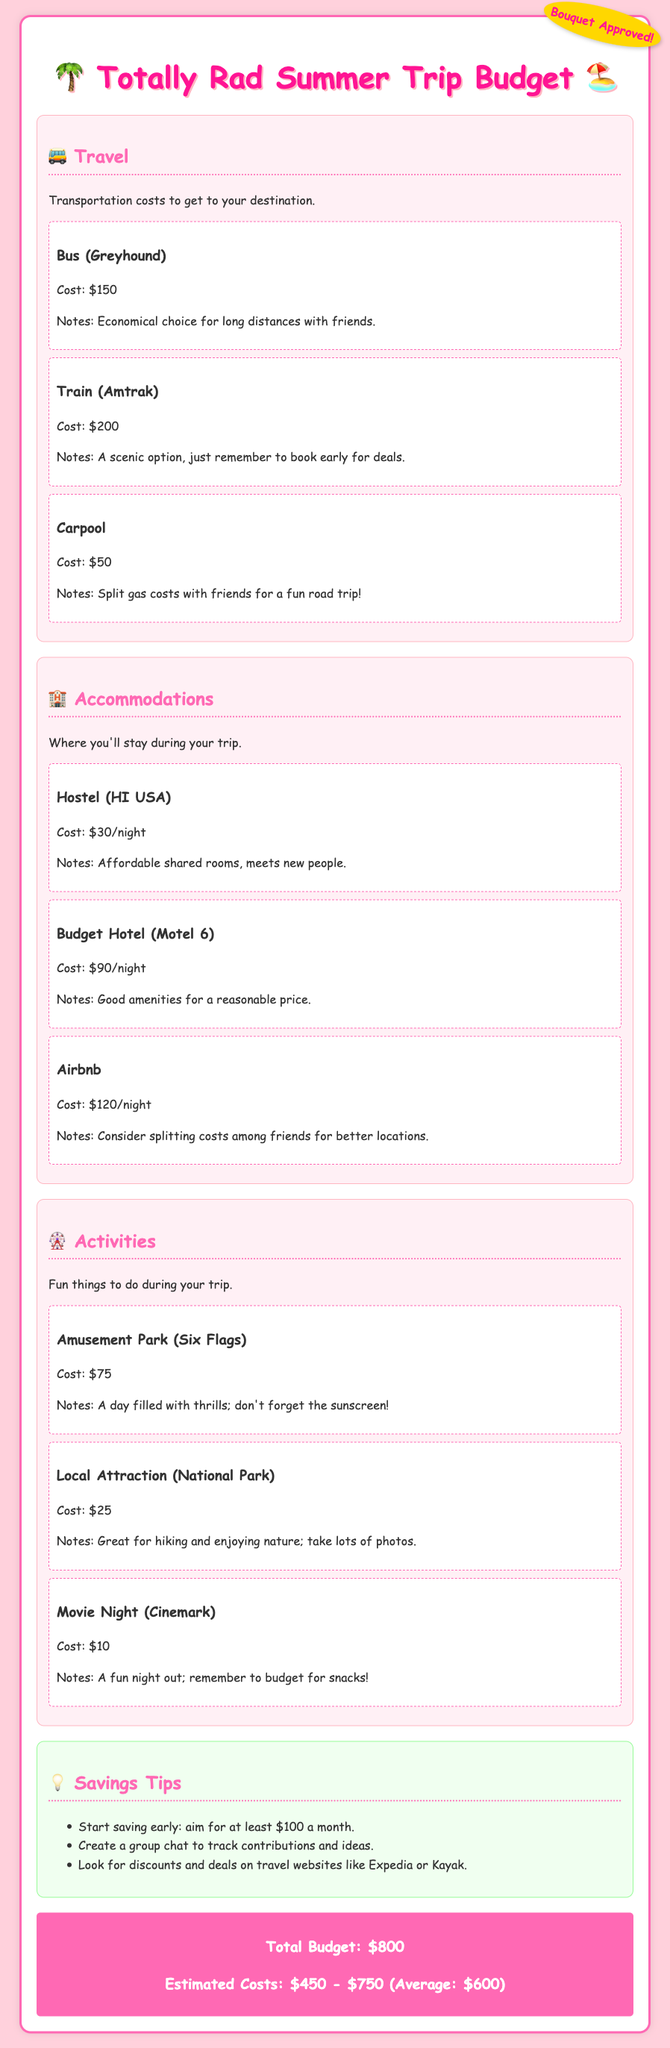What is the most economical travel option? The document lists the travel options and their costs, showing that the carpool option costs only $50, making it the cheapest choice.
Answer: $50 What is the cost per night for a hostel? The budget section details that the hostel costs $30 per night for accommodation.
Answer: $30/night How much should you start saving each month? The savings tips mention aiming for at least $100 a month for the trip.
Answer: $100 What is the cost of a ticket to Six Flags? The activities section specifies that a ticket to the amusement park costs $75.
Answer: $75 What is the average estimated cost for the trip? The document provides an average estimated cost of $600 for the trip.
Answer: $600 What type of accommodation is the most expensive? Among the options given, the Airbnb has the highest cost of $120 per night.
Answer: $120/night Which activity costs the least? The document lists the local attraction at $25 as the least expensive activity.
Answer: $25 What is the total budget for the trip? The total budget mentioned in the document amounts to $800, summarizing all costs.
Answer: $800 